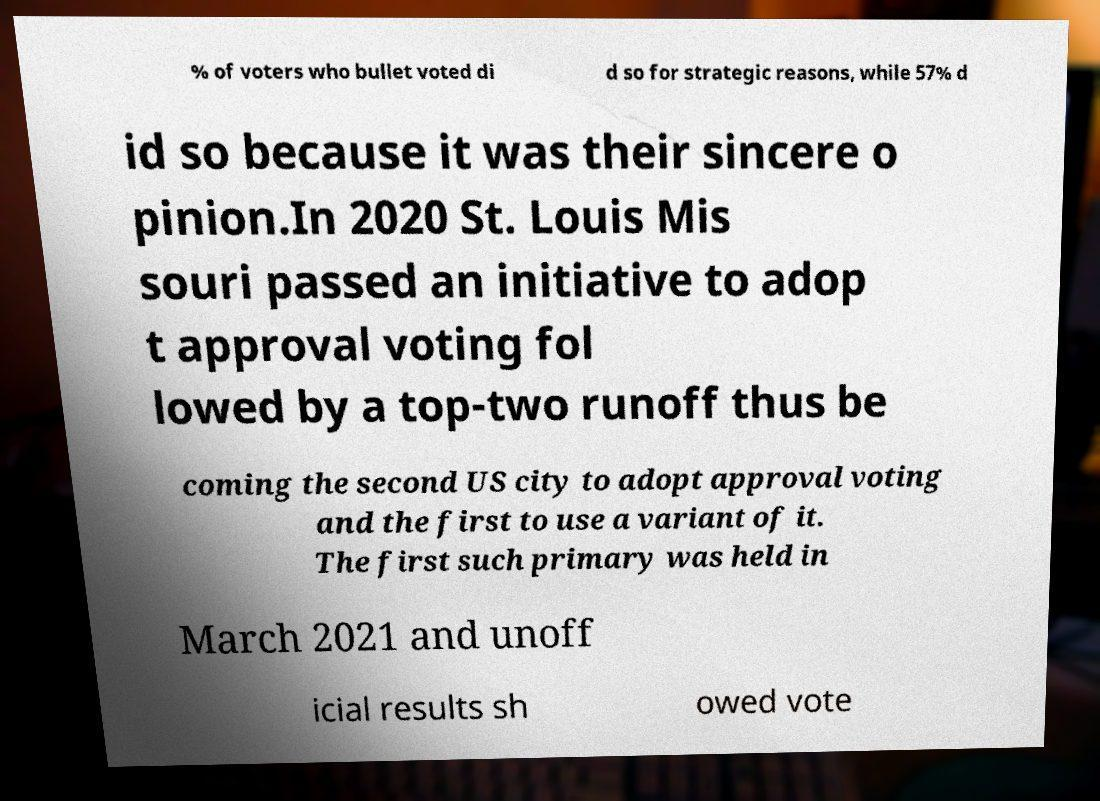Please read and relay the text visible in this image. What does it say? % of voters who bullet voted di d so for strategic reasons, while 57% d id so because it was their sincere o pinion.In 2020 St. Louis Mis souri passed an initiative to adop t approval voting fol lowed by a top-two runoff thus be coming the second US city to adopt approval voting and the first to use a variant of it. The first such primary was held in March 2021 and unoff icial results sh owed vote 